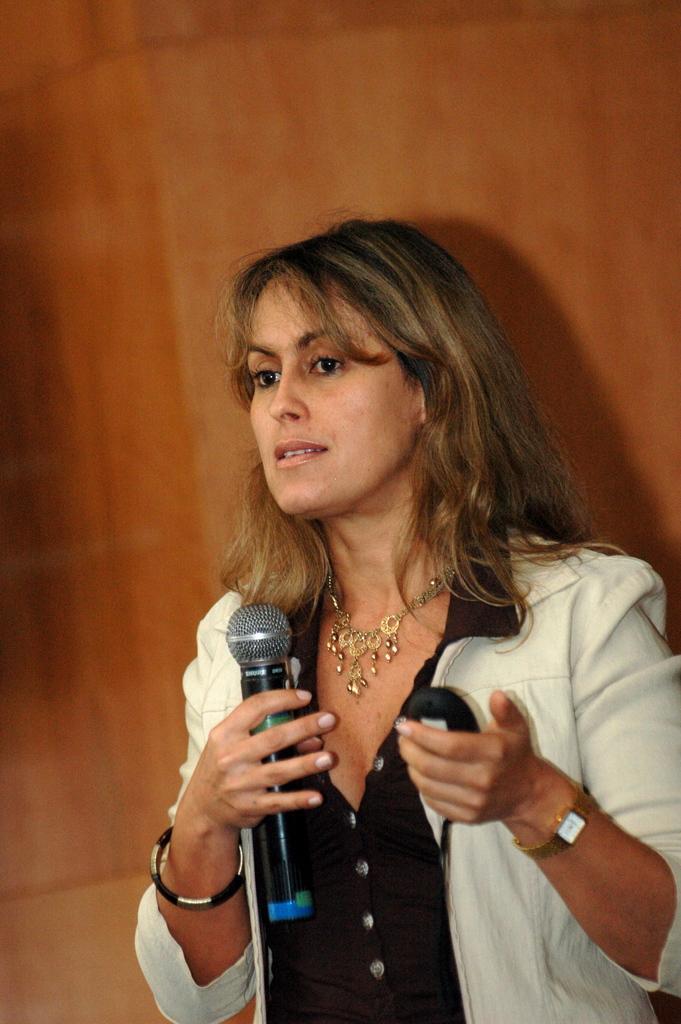Could you give a brief overview of what you see in this image? In the picture we can see a woman standing and holding a microphone and on the other hand she is holding a mobile phone, she is wearing a blazer which is white in color and a black shirt and with a necklace and in the background we can see a wall which is brown in color. 